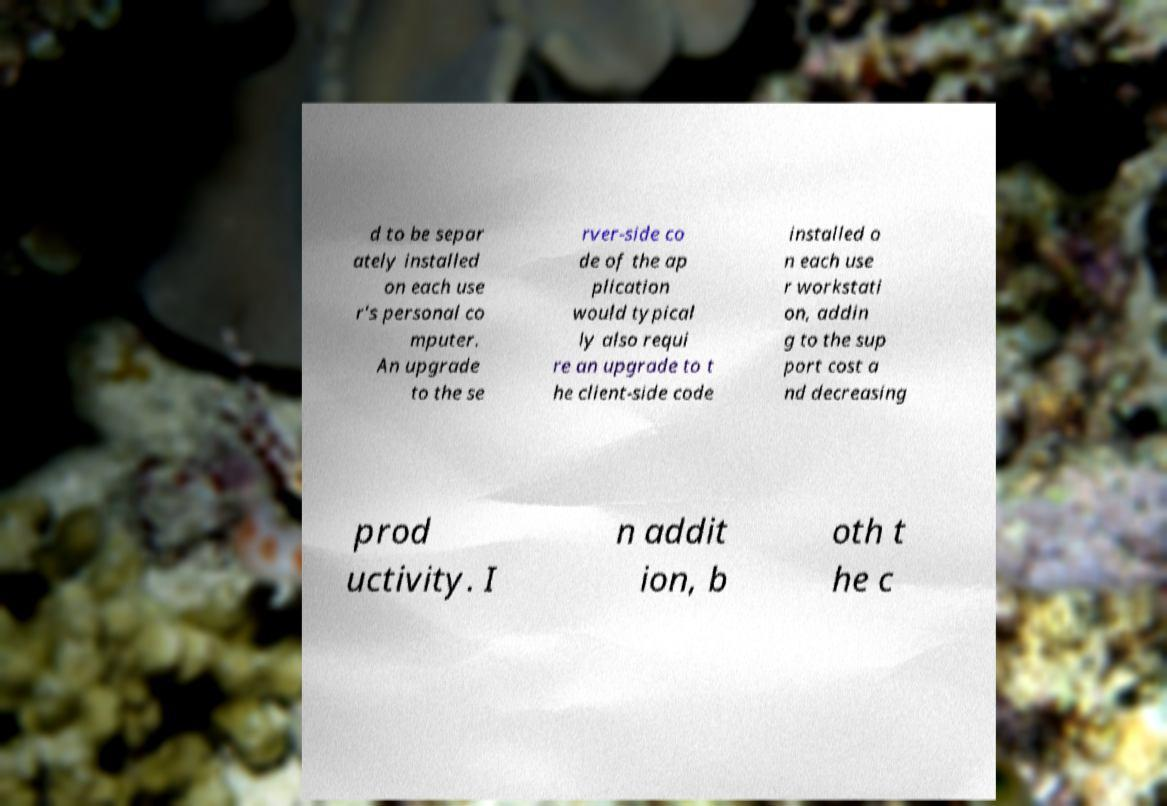For documentation purposes, I need the text within this image transcribed. Could you provide that? d to be separ ately installed on each use r's personal co mputer. An upgrade to the se rver-side co de of the ap plication would typical ly also requi re an upgrade to t he client-side code installed o n each use r workstati on, addin g to the sup port cost a nd decreasing prod uctivity. I n addit ion, b oth t he c 